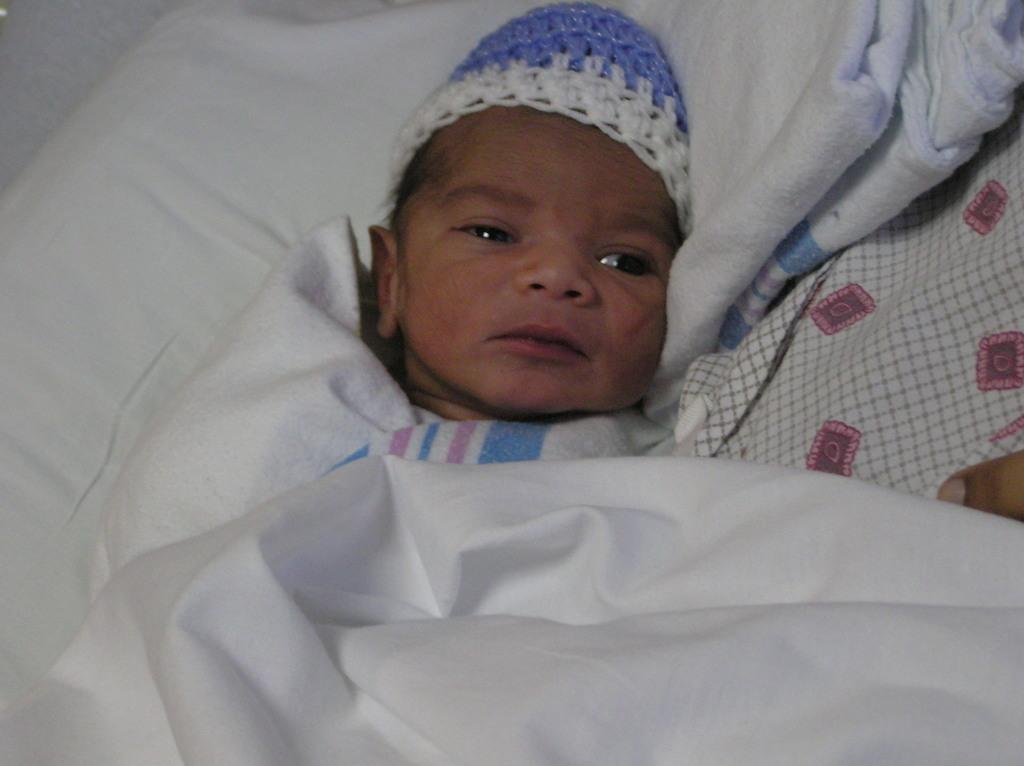What is the main subject of the image? There is a small baby in the center of the image. What else can be seen in the image besides the baby? There are blankets in the image. What type of frog can be seen interacting with the baby in the image? There is no frog present in the image; it only features a small baby and blankets. What is the baby's tendency towards eating lunch in the image? There is no information about the baby's eating habits or a lunchroom in the image. 